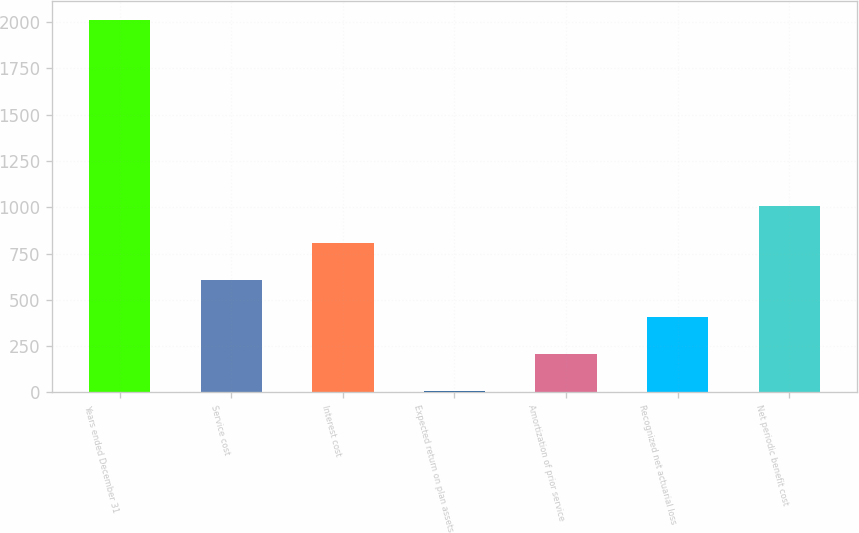Convert chart. <chart><loc_0><loc_0><loc_500><loc_500><bar_chart><fcel>Years ended December 31<fcel>Service cost<fcel>Interest cost<fcel>Expected return on plan assets<fcel>Amortization of prior service<fcel>Recognized net actuarial loss<fcel>Net periodic benefit cost<nl><fcel>2011<fcel>607.5<fcel>808<fcel>6<fcel>206.5<fcel>407<fcel>1008.5<nl></chart> 